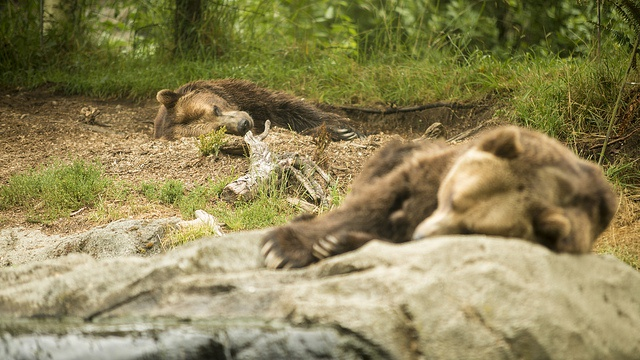Describe the objects in this image and their specific colors. I can see bear in black, olive, and tan tones and bear in black, gray, tan, and olive tones in this image. 